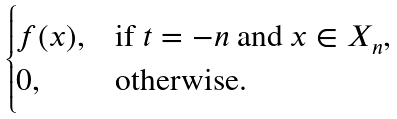Convert formula to latex. <formula><loc_0><loc_0><loc_500><loc_500>\begin{cases} f ( x ) , & \text {if $t=-n$ and $x \in X_{n}$,} \\ 0 , & \text {otherwise.} \end{cases}</formula> 